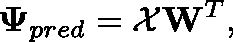Convert formula to latex. <formula><loc_0><loc_0><loc_500><loc_500>\Psi _ { p r e d } = \mathcal { X } W ^ { T } ,</formula> 